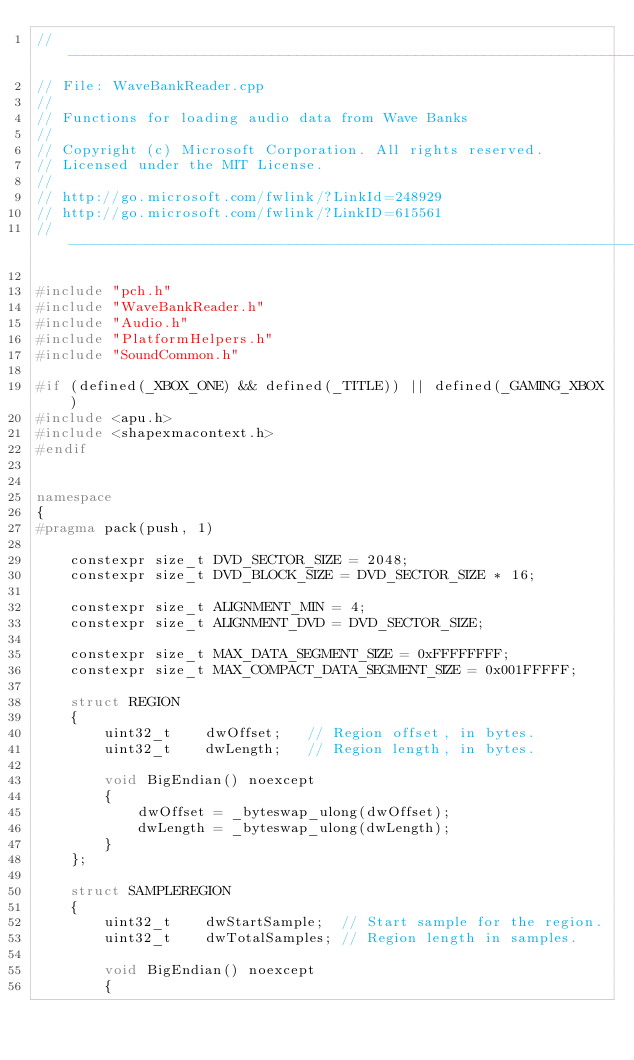Convert code to text. <code><loc_0><loc_0><loc_500><loc_500><_C++_>//--------------------------------------------------------------------------------------
// File: WaveBankReader.cpp
//
// Functions for loading audio data from Wave Banks
//
// Copyright (c) Microsoft Corporation. All rights reserved.
// Licensed under the MIT License.
//
// http://go.microsoft.com/fwlink/?LinkId=248929
// http://go.microsoft.com/fwlink/?LinkID=615561
//-------------------------------------------------------------------------------------

#include "pch.h"
#include "WaveBankReader.h"
#include "Audio.h"
#include "PlatformHelpers.h"
#include "SoundCommon.h"

#if (defined(_XBOX_ONE) && defined(_TITLE)) || defined(_GAMING_XBOX)
#include <apu.h>
#include <shapexmacontext.h>
#endif


namespace
{
#pragma pack(push, 1)

    constexpr size_t DVD_SECTOR_SIZE = 2048;
    constexpr size_t DVD_BLOCK_SIZE = DVD_SECTOR_SIZE * 16;

    constexpr size_t ALIGNMENT_MIN = 4;
    constexpr size_t ALIGNMENT_DVD = DVD_SECTOR_SIZE;

    constexpr size_t MAX_DATA_SEGMENT_SIZE = 0xFFFFFFFF;
    constexpr size_t MAX_COMPACT_DATA_SEGMENT_SIZE = 0x001FFFFF;

    struct REGION
    {
        uint32_t    dwOffset;   // Region offset, in bytes.
        uint32_t    dwLength;   // Region length, in bytes.

        void BigEndian() noexcept
        {
            dwOffset = _byteswap_ulong(dwOffset);
            dwLength = _byteswap_ulong(dwLength);
        }
    };

    struct SAMPLEREGION
    {
        uint32_t    dwStartSample;  // Start sample for the region.
        uint32_t    dwTotalSamples; // Region length in samples.

        void BigEndian() noexcept
        {</code> 